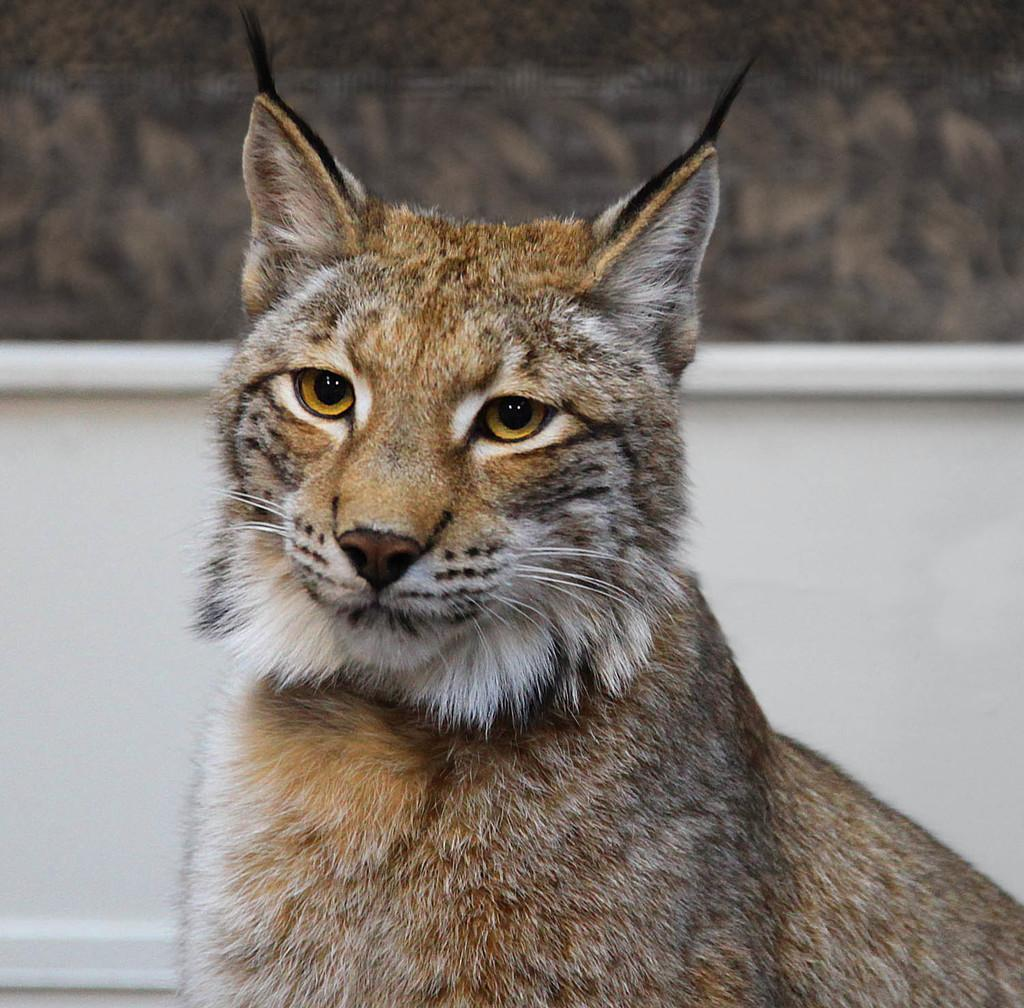What type of animal is in the picture? There is a wild cat in the picture. Can you describe the wild cat's appearance? The wild cat has fur. What can be seen in the background of the picture? There is a white wall in the background of the picture. What type of camera is being used to take the picture of the wild cat? There is no information about a camera being used to take the picture, so we cannot determine the type of camera. 